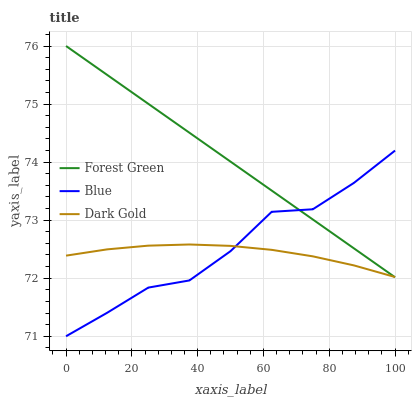Does Dark Gold have the minimum area under the curve?
Answer yes or no. Yes. Does Forest Green have the maximum area under the curve?
Answer yes or no. Yes. Does Forest Green have the minimum area under the curve?
Answer yes or no. No. Does Dark Gold have the maximum area under the curve?
Answer yes or no. No. Is Forest Green the smoothest?
Answer yes or no. Yes. Is Blue the roughest?
Answer yes or no. Yes. Is Dark Gold the smoothest?
Answer yes or no. No. Is Dark Gold the roughest?
Answer yes or no. No. Does Forest Green have the lowest value?
Answer yes or no. No. Does Dark Gold have the highest value?
Answer yes or no. No. 